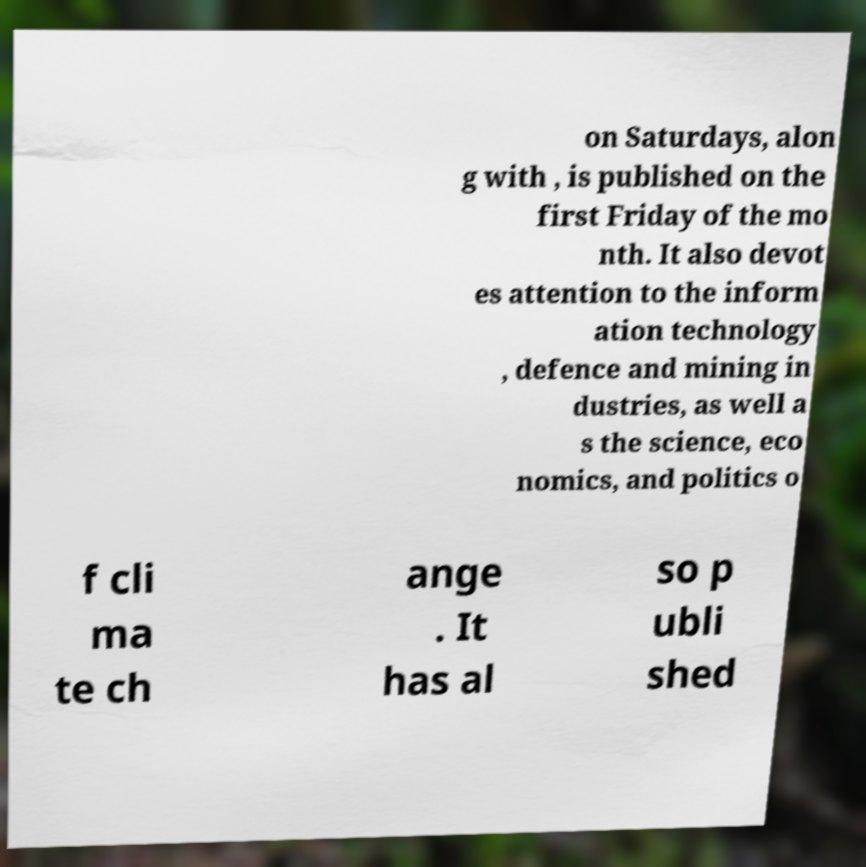Could you extract and type out the text from this image? on Saturdays, alon g with , is published on the first Friday of the mo nth. It also devot es attention to the inform ation technology , defence and mining in dustries, as well a s the science, eco nomics, and politics o f cli ma te ch ange . It has al so p ubli shed 